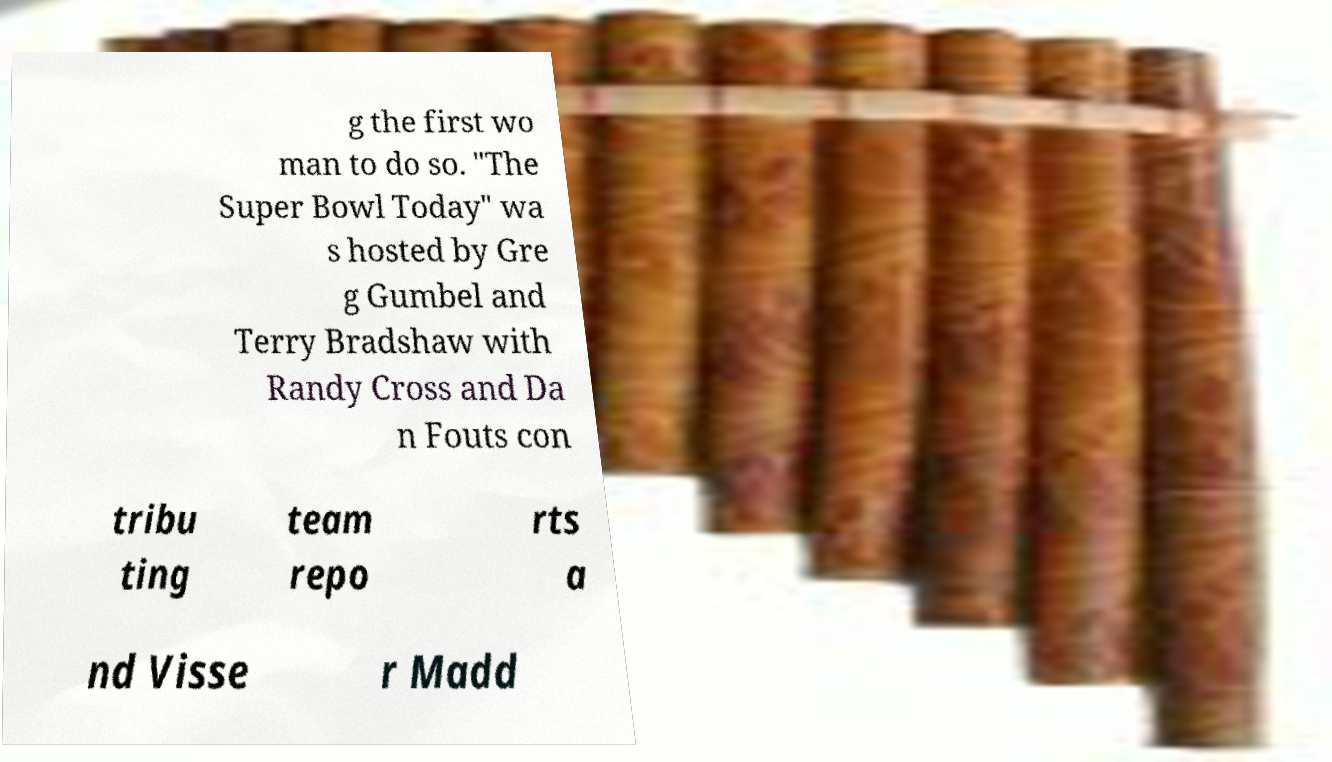Can you accurately transcribe the text from the provided image for me? g the first wo man to do so. "The Super Bowl Today" wa s hosted by Gre g Gumbel and Terry Bradshaw with Randy Cross and Da n Fouts con tribu ting team repo rts a nd Visse r Madd 